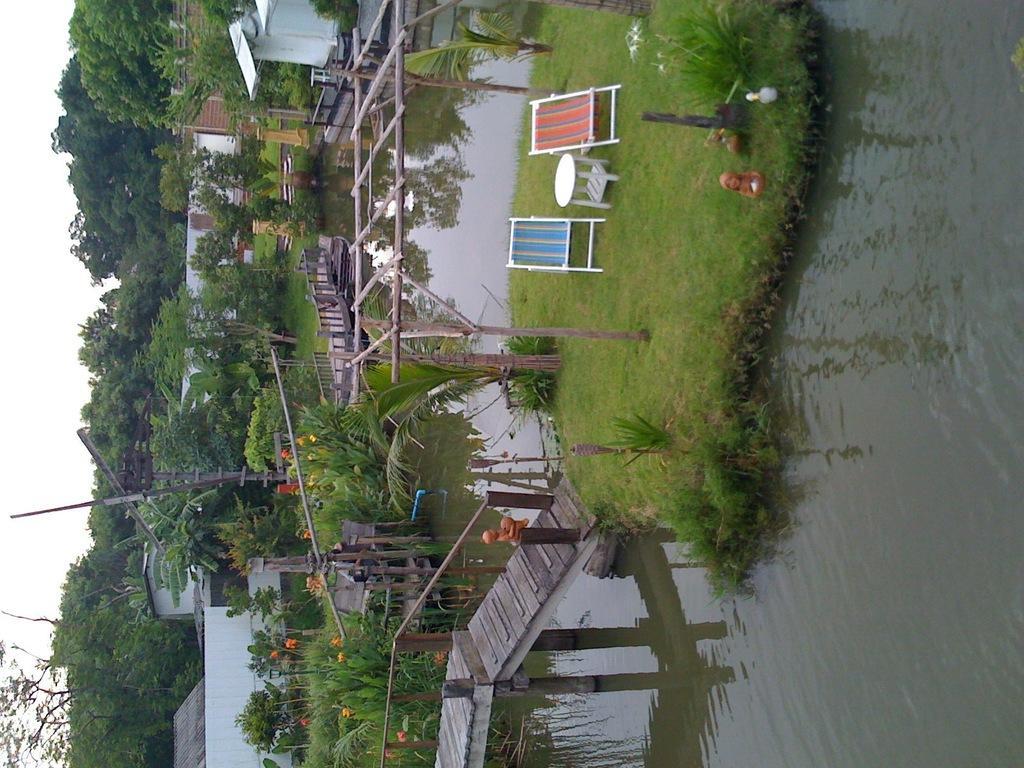Could you give a brief overview of what you see in this image? In this image I see wooden platforms, green grass on which there are 2 chairs and a table and I see plants and trees and I see houses and I see the water. In the background I see the sky. 